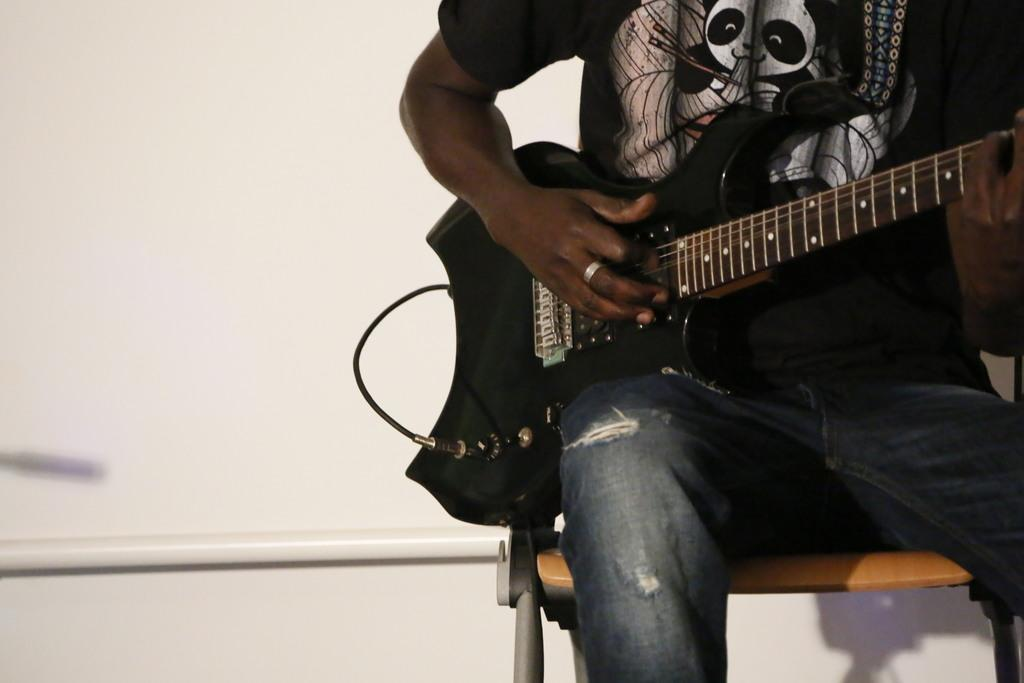Who or what is the main subject in the image? There is a person in the image. What is the person doing in the image? The person is sitting on a chair and holding a guitar. What can be seen in the background of the image? There is a wall in the background of the image. What type of quartz can be seen on the person's wrist in the image? There is no quartz visible on the person's wrist in the image. How long does the person play the guitar in the image? The image is a still photograph, so it does not show the person playing the guitar or indicate how long they might play. 